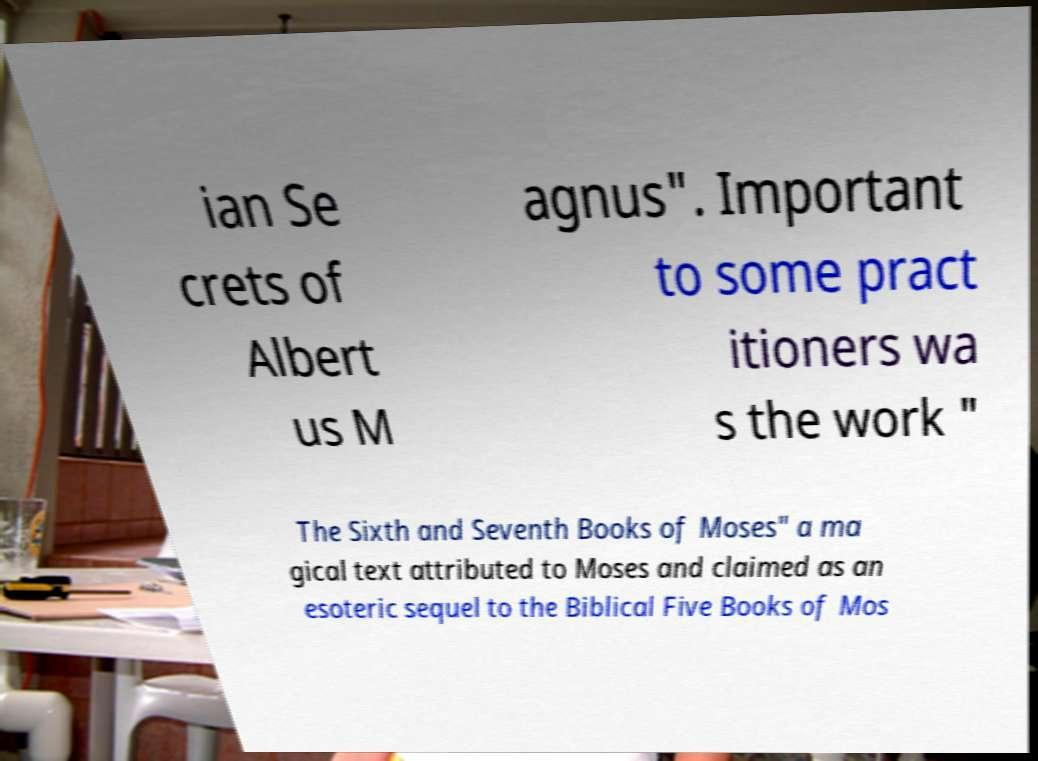Please read and relay the text visible in this image. What does it say? ian Se crets of Albert us M agnus". Important to some pract itioners wa s the work " The Sixth and Seventh Books of Moses" a ma gical text attributed to Moses and claimed as an esoteric sequel to the Biblical Five Books of Mos 